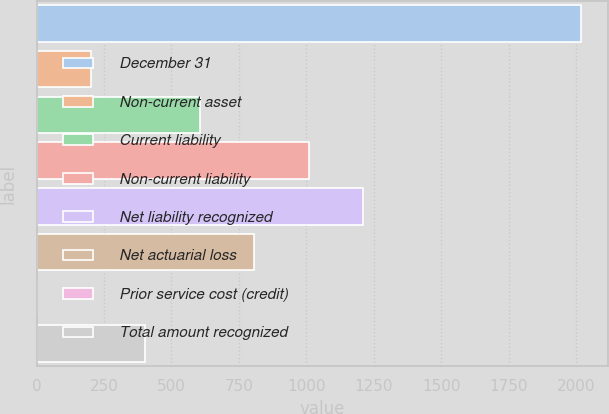Convert chart. <chart><loc_0><loc_0><loc_500><loc_500><bar_chart><fcel>December 31<fcel>Non-current asset<fcel>Current liability<fcel>Non-current liability<fcel>Net liability recognized<fcel>Net actuarial loss<fcel>Prior service cost (credit)<fcel>Total amount recognized<nl><fcel>2018<fcel>202.07<fcel>605.61<fcel>1009.15<fcel>1210.92<fcel>807.38<fcel>0.3<fcel>403.84<nl></chart> 